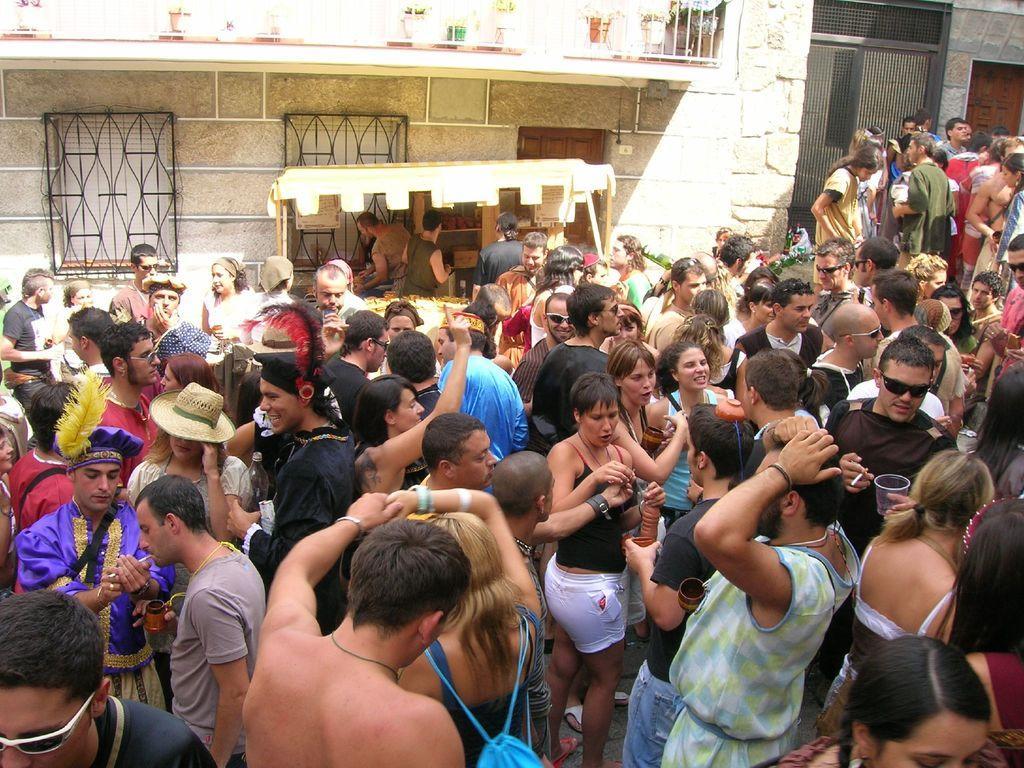Describe this image in one or two sentences. In the background we can see plants with pots, windows with grills and people standing. A the bottom portion of the picture we can see people standing. Among them few wore goggles. 